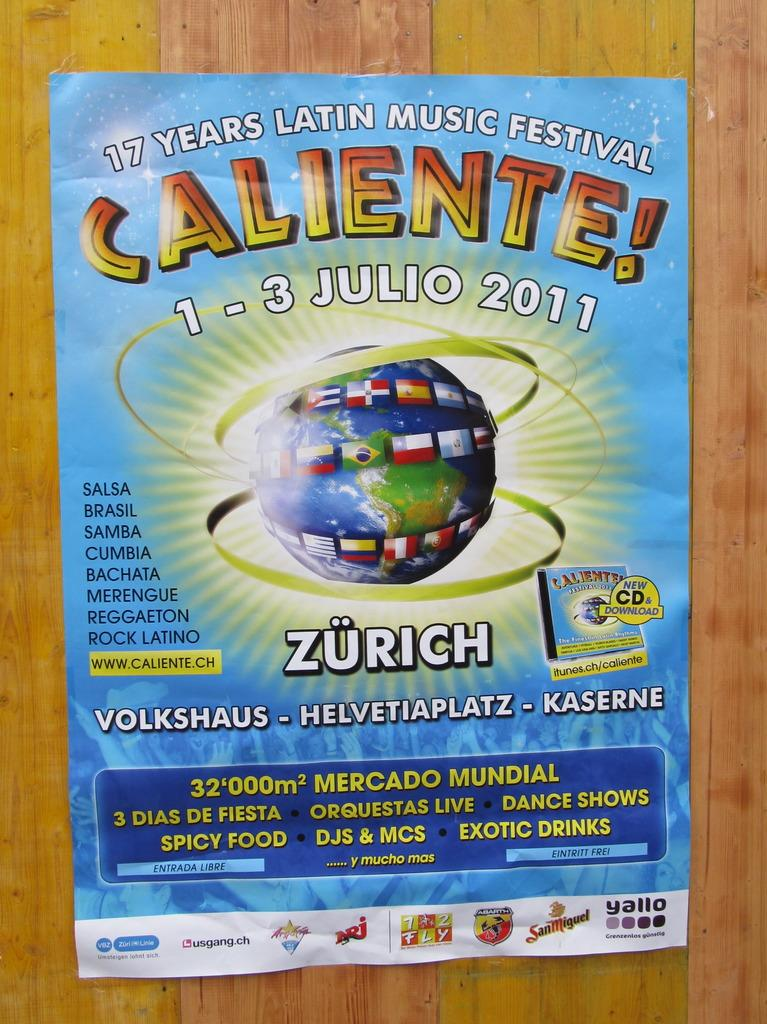<image>
Write a terse but informative summary of the picture. A flyer advertises a 17 years Latin music festival. 